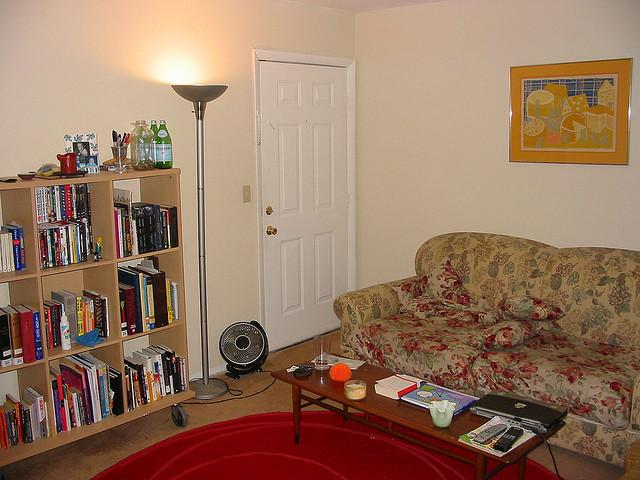Which electronic device is likely located in front of the coffee table? television 